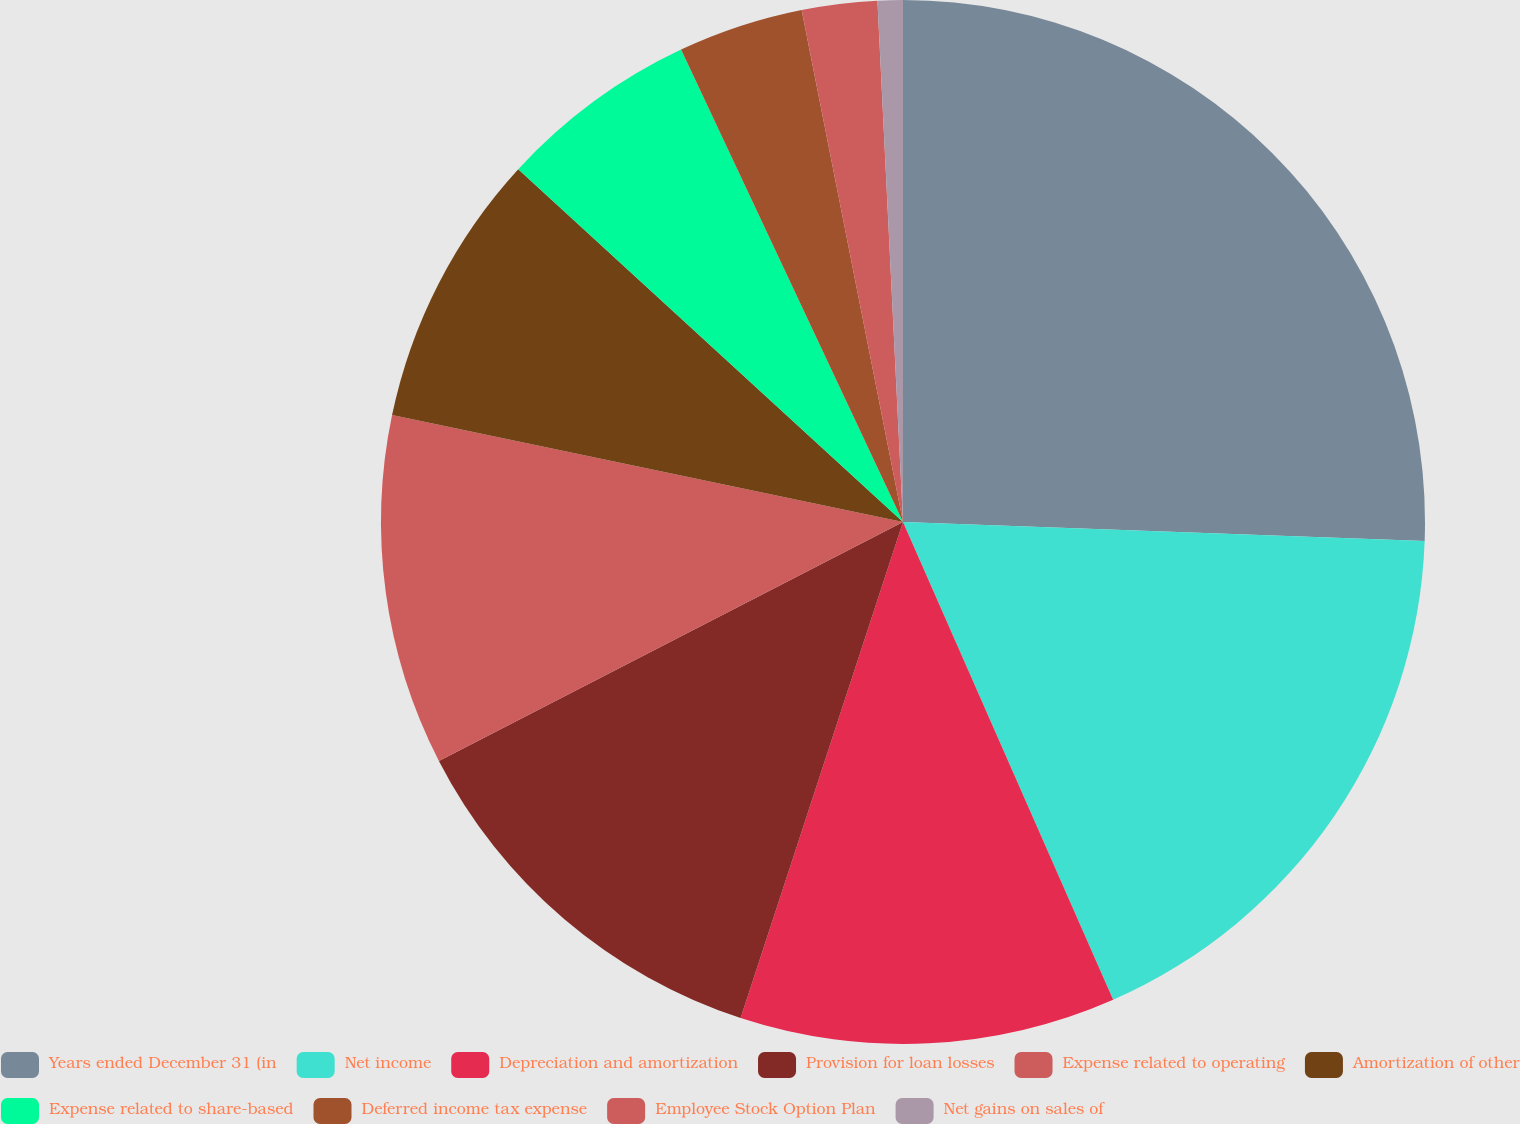Convert chart. <chart><loc_0><loc_0><loc_500><loc_500><pie_chart><fcel>Years ended December 31 (in<fcel>Net income<fcel>Depreciation and amortization<fcel>Provision for loan losses<fcel>Expense related to operating<fcel>Amortization of other<fcel>Expense related to share-based<fcel>Deferred income tax expense<fcel>Employee Stock Option Plan<fcel>Net gains on sales of<nl><fcel>25.58%<fcel>17.83%<fcel>11.63%<fcel>12.4%<fcel>10.85%<fcel>8.53%<fcel>6.2%<fcel>3.88%<fcel>2.33%<fcel>0.78%<nl></chart> 